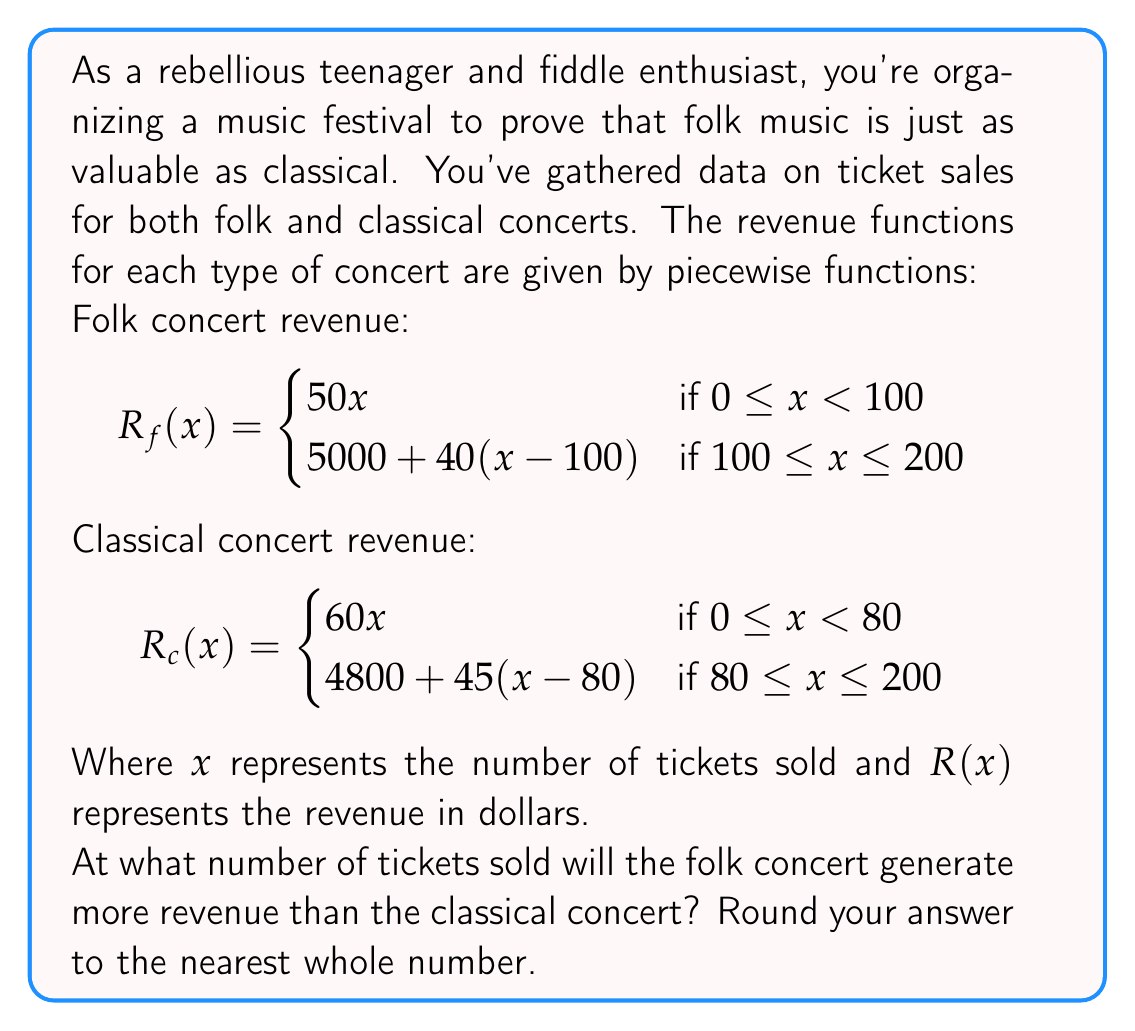Teach me how to tackle this problem. To solve this problem, we need to find the point where the folk concert revenue exceeds the classical concert revenue. Let's approach this step-by-step:

1) First, we need to set up an inequality:
   $R_f(x) > R_c(x)$

2) We need to consider different cases based on the piecewise functions:

   Case 1: $0 \leq x < 80$
   $50x > 60x$
   This is never true, so the folk concert doesn't generate more revenue in this range.

   Case 2: $80 \leq x < 100$
   $50x > 4800 + 45(x-80)$
   $50x > 4800 + 45x - 3600$
   $50x > 1200 + 45x$
   $5x > 1200$
   $x > 240$
   This is outside the range for this case, so we move to the next case.

   Case 3: $100 \leq x \leq 200$
   $5000 + 40(x-100) > 4800 + 45(x-80)$
   $5000 + 40x - 4000 > 4800 + 45x - 3600$
   $1000 + 40x > 1200 + 45x$
   $-200 > 5x$
   $-40 > x$

3) The inequality in Case 3 is always true for the given range. This means that as soon as we enter this range (at $x = 100$), the folk concert generates more revenue.

4) Therefore, the folk concert will generate more revenue starting at 100 tickets sold.
Answer: The folk concert will generate more revenue than the classical concert starting at 100 tickets sold. 